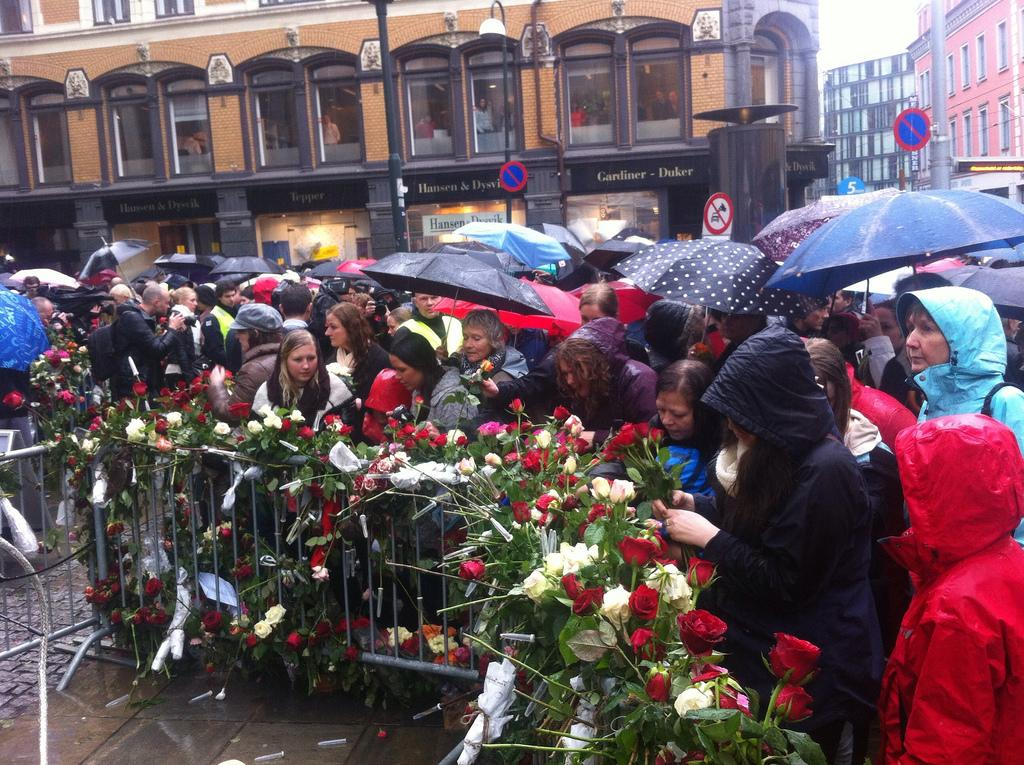Identify the main colors and items featured in the image. The image features red and white roses, people in red, blue, and black jackets, several umbrellas, and a gray railing. Provide a brief overview of the scene depicted in the image. The image shows people with various-colored jackets and umbrellas gathered around a fence with red and white roses along a gray railing. State the purpose of gathering for the people in the image. The people are likely admiring the red and white roses displayed along the fence and the gray railing, while holding umbrellas due to rain. Discuss the overall atmosphere and theme of the image. The image has a rainy day atmosphere with people wearing jackets and holding umbrellas standing near a fence adorned with flowers. Describe the actions of the people in the image. The people are gathered around a fence adorned with red and white roses, some holding umbrellas to protect themselves from the rain. Describe the appearance of the flowers and their surroundings in the image. The red and white roses are blooming along a fence with a gray railing, surrounded by people wearing jackets and holding umbrellas. Enumerate the various street elements depicted in the image. A red and blue street sign, a gray railing, a fence with red and white roses, and people with different-colored jackets and umbrellas. Detail the different elements present in the image related to the weather. People are wearing jackets and holding umbrellas of various colors and designs, likely to shield themselves from the rain. List the various types of jackets and umbrellas observed in the image. Jackets: red, black, light blue, grey. Umbrellas: black with polka dots, blue, red, black, spotted. 